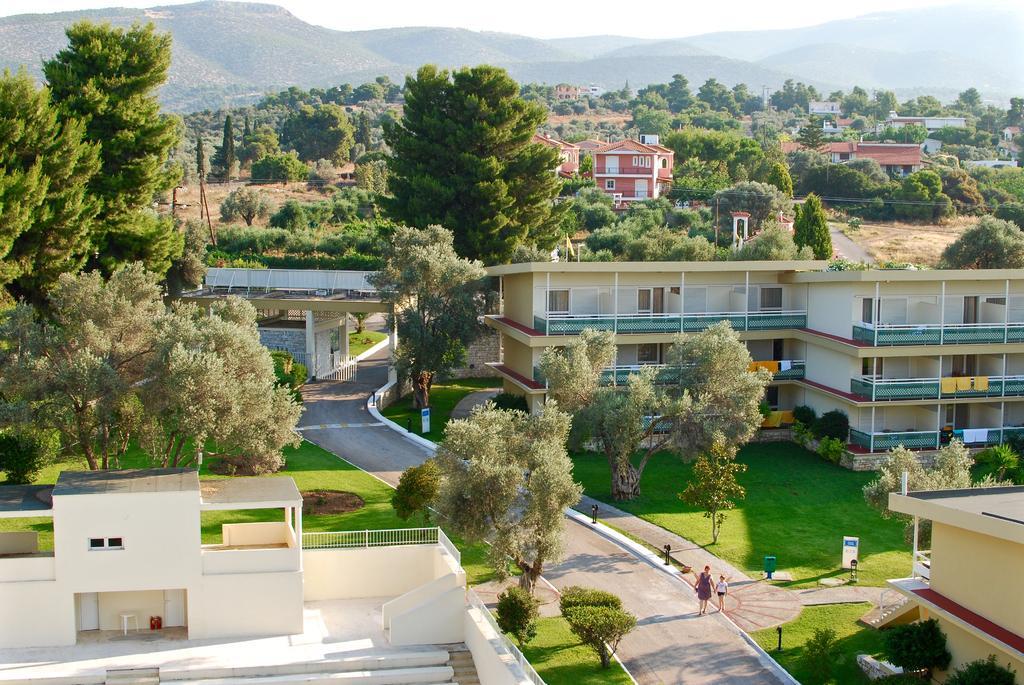Please provide a concise description of this image. In this picture we can see people on the ground, here we can see name boards, grass, trees, buildings, clothes and some objects and in the background we can see mountains, sky. 